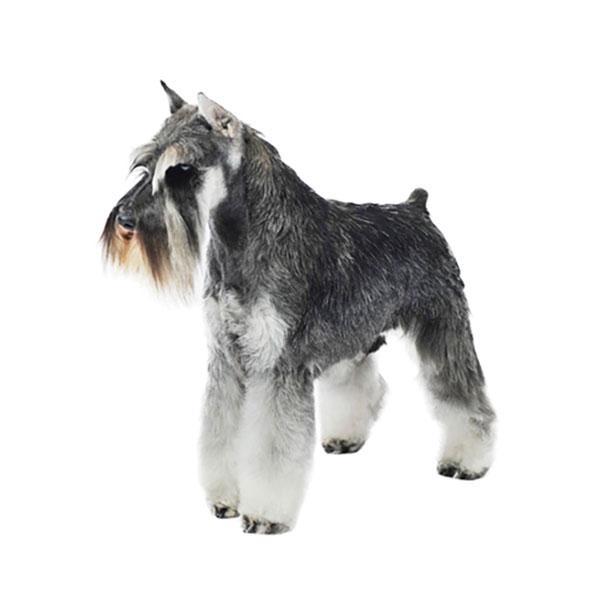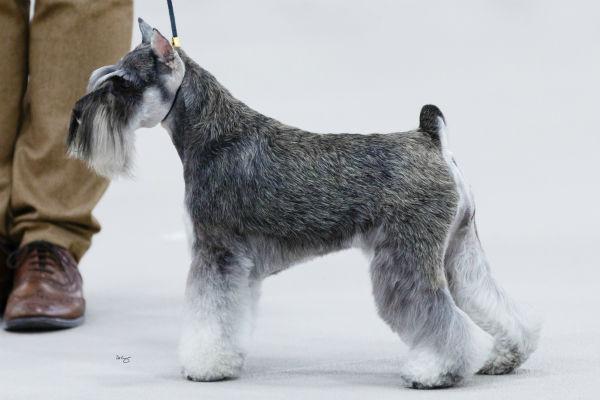The first image is the image on the left, the second image is the image on the right. Assess this claim about the two images: "All dogs are facing to the left.". Correct or not? Answer yes or no. Yes. 